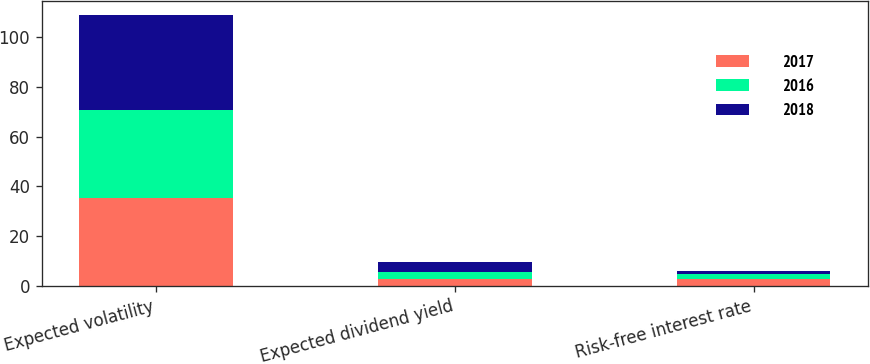Convert chart. <chart><loc_0><loc_0><loc_500><loc_500><stacked_bar_chart><ecel><fcel>Expected volatility<fcel>Expected dividend yield<fcel>Risk-free interest rate<nl><fcel>2017<fcel>35.39<fcel>2.88<fcel>2.64<nl><fcel>2016<fcel>35.29<fcel>2.84<fcel>2.06<nl><fcel>2018<fcel>38.36<fcel>3.92<fcel>1.25<nl></chart> 